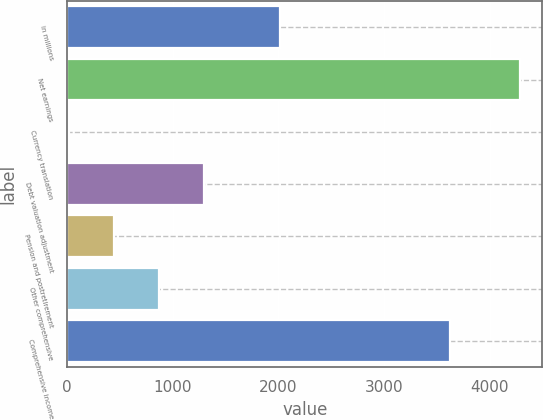Convert chart to OTSL. <chart><loc_0><loc_0><loc_500><loc_500><bar_chart><fcel>in millions<fcel>Net earnings<fcel>Currency translation<fcel>Debt valuation adjustment<fcel>Pension and postretirement<fcel>Other comprehensive<fcel>Comprehensive income<nl><fcel>2017<fcel>4286<fcel>22<fcel>1301.2<fcel>448.4<fcel>874.8<fcel>3622<nl></chart> 